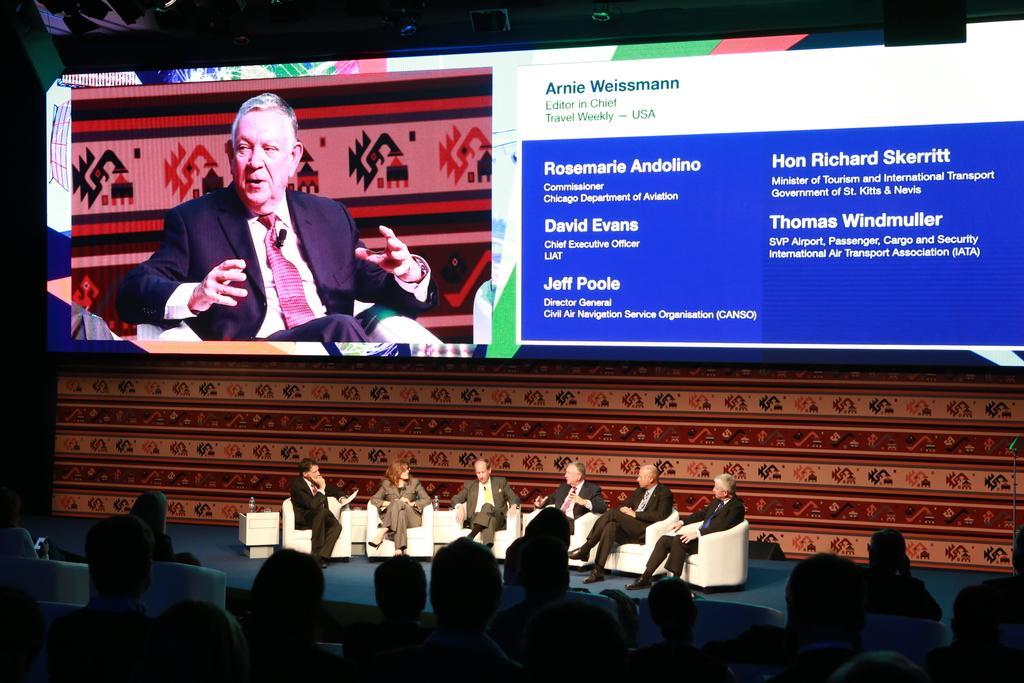Could you give a brief overview of what you see in this image? In this image at the top I can see the screen and I can see person image and text and at the bottom I can see persons sitting on the chair. 